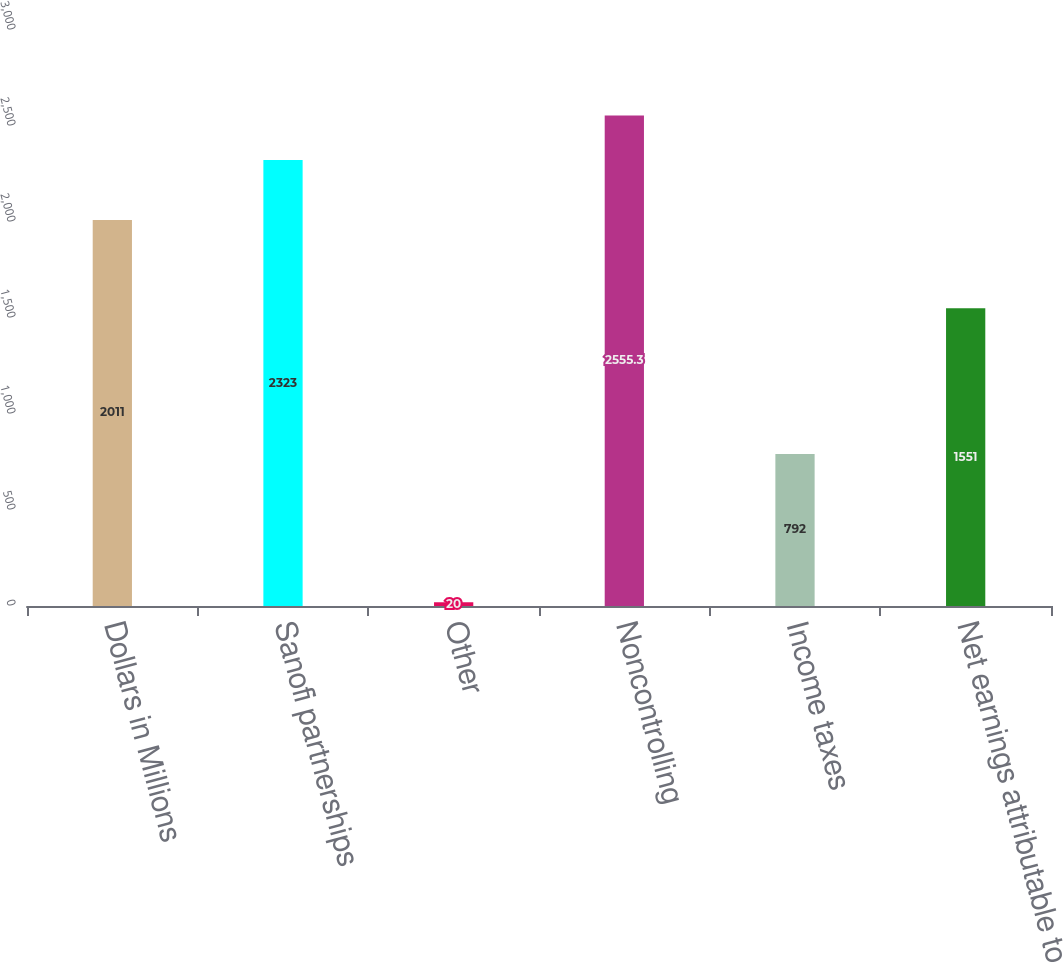Convert chart. <chart><loc_0><loc_0><loc_500><loc_500><bar_chart><fcel>Dollars in Millions<fcel>Sanofi partnerships<fcel>Other<fcel>Noncontrolling<fcel>Income taxes<fcel>Net earnings attributable to<nl><fcel>2011<fcel>2323<fcel>20<fcel>2555.3<fcel>792<fcel>1551<nl></chart> 